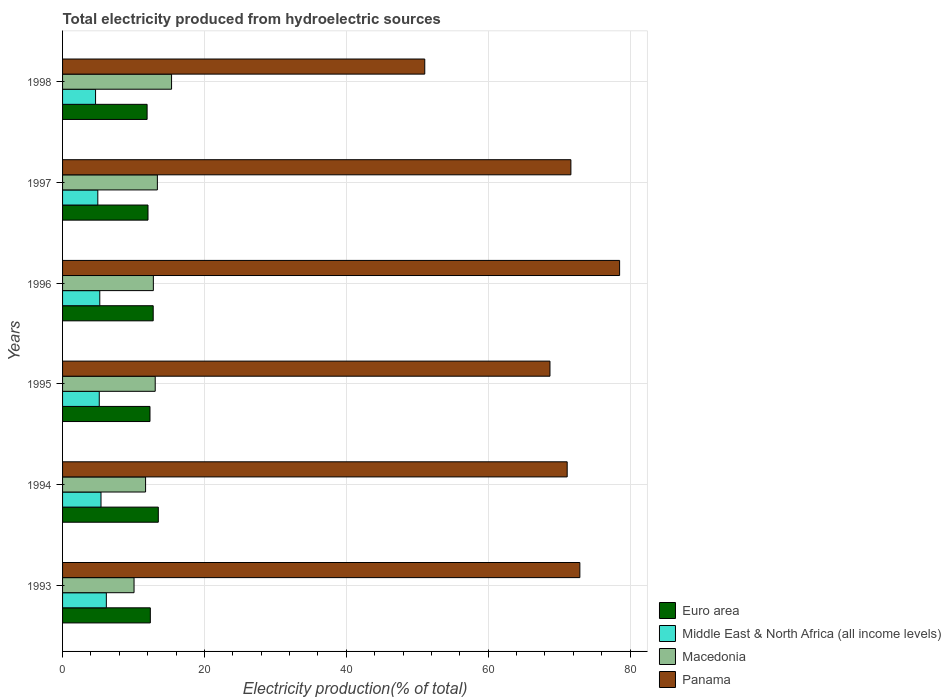How many different coloured bars are there?
Provide a short and direct response. 4. How many groups of bars are there?
Give a very brief answer. 6. Are the number of bars on each tick of the Y-axis equal?
Provide a short and direct response. Yes. How many bars are there on the 4th tick from the top?
Offer a terse response. 4. What is the total electricity produced in Euro area in 1996?
Keep it short and to the point. 12.78. Across all years, what is the maximum total electricity produced in Macedonia?
Offer a terse response. 15.37. Across all years, what is the minimum total electricity produced in Euro area?
Offer a terse response. 11.92. What is the total total electricity produced in Euro area in the graph?
Offer a very short reply. 74.93. What is the difference between the total electricity produced in Panama in 1994 and that in 1995?
Your answer should be very brief. 2.43. What is the difference between the total electricity produced in Panama in 1994 and the total electricity produced in Macedonia in 1998?
Offer a very short reply. 55.77. What is the average total electricity produced in Euro area per year?
Your answer should be very brief. 12.49. In the year 1995, what is the difference between the total electricity produced in Panama and total electricity produced in Middle East & North Africa (all income levels)?
Make the answer very short. 63.54. What is the ratio of the total electricity produced in Middle East & North Africa (all income levels) in 1994 to that in 1997?
Keep it short and to the point. 1.09. What is the difference between the highest and the second highest total electricity produced in Euro area?
Provide a succinct answer. 0.72. What is the difference between the highest and the lowest total electricity produced in Middle East & North Africa (all income levels)?
Offer a terse response. 1.52. Is the sum of the total electricity produced in Euro area in 1994 and 1995 greater than the maximum total electricity produced in Middle East & North Africa (all income levels) across all years?
Make the answer very short. Yes. What does the 3rd bar from the top in 1998 represents?
Provide a succinct answer. Middle East & North Africa (all income levels). What does the 1st bar from the bottom in 1995 represents?
Offer a very short reply. Euro area. Are all the bars in the graph horizontal?
Your response must be concise. Yes. Are the values on the major ticks of X-axis written in scientific E-notation?
Your answer should be compact. No. How many legend labels are there?
Your answer should be very brief. 4. How are the legend labels stacked?
Offer a terse response. Vertical. What is the title of the graph?
Your response must be concise. Total electricity produced from hydroelectric sources. Does "Uzbekistan" appear as one of the legend labels in the graph?
Ensure brevity in your answer.  No. What is the label or title of the X-axis?
Provide a succinct answer. Electricity production(% of total). What is the label or title of the Y-axis?
Ensure brevity in your answer.  Years. What is the Electricity production(% of total) in Euro area in 1993?
Give a very brief answer. 12.37. What is the Electricity production(% of total) in Middle East & North Africa (all income levels) in 1993?
Offer a very short reply. 6.17. What is the Electricity production(% of total) of Macedonia in 1993?
Your answer should be very brief. 10.08. What is the Electricity production(% of total) of Panama in 1993?
Offer a very short reply. 72.93. What is the Electricity production(% of total) of Euro area in 1994?
Your response must be concise. 13.5. What is the Electricity production(% of total) of Middle East & North Africa (all income levels) in 1994?
Give a very brief answer. 5.42. What is the Electricity production(% of total) of Macedonia in 1994?
Your answer should be very brief. 11.7. What is the Electricity production(% of total) in Panama in 1994?
Give a very brief answer. 71.14. What is the Electricity production(% of total) in Euro area in 1995?
Provide a succinct answer. 12.32. What is the Electricity production(% of total) of Middle East & North Africa (all income levels) in 1995?
Offer a very short reply. 5.17. What is the Electricity production(% of total) of Macedonia in 1995?
Offer a very short reply. 13.06. What is the Electricity production(% of total) of Panama in 1995?
Keep it short and to the point. 68.71. What is the Electricity production(% of total) in Euro area in 1996?
Give a very brief answer. 12.78. What is the Electricity production(% of total) of Middle East & North Africa (all income levels) in 1996?
Your answer should be very brief. 5.25. What is the Electricity production(% of total) of Macedonia in 1996?
Ensure brevity in your answer.  12.8. What is the Electricity production(% of total) of Panama in 1996?
Give a very brief answer. 78.53. What is the Electricity production(% of total) in Euro area in 1997?
Give a very brief answer. 12.04. What is the Electricity production(% of total) in Middle East & North Africa (all income levels) in 1997?
Offer a very short reply. 4.97. What is the Electricity production(% of total) of Macedonia in 1997?
Provide a short and direct response. 13.37. What is the Electricity production(% of total) of Panama in 1997?
Offer a very short reply. 71.66. What is the Electricity production(% of total) of Euro area in 1998?
Provide a succinct answer. 11.92. What is the Electricity production(% of total) in Middle East & North Africa (all income levels) in 1998?
Offer a very short reply. 4.65. What is the Electricity production(% of total) in Macedonia in 1998?
Keep it short and to the point. 15.37. What is the Electricity production(% of total) of Panama in 1998?
Provide a short and direct response. 51.06. Across all years, what is the maximum Electricity production(% of total) in Euro area?
Your answer should be compact. 13.5. Across all years, what is the maximum Electricity production(% of total) in Middle East & North Africa (all income levels)?
Provide a short and direct response. 6.17. Across all years, what is the maximum Electricity production(% of total) in Macedonia?
Provide a succinct answer. 15.37. Across all years, what is the maximum Electricity production(% of total) in Panama?
Provide a short and direct response. 78.53. Across all years, what is the minimum Electricity production(% of total) in Euro area?
Provide a short and direct response. 11.92. Across all years, what is the minimum Electricity production(% of total) of Middle East & North Africa (all income levels)?
Ensure brevity in your answer.  4.65. Across all years, what is the minimum Electricity production(% of total) in Macedonia?
Provide a succinct answer. 10.08. Across all years, what is the minimum Electricity production(% of total) of Panama?
Give a very brief answer. 51.06. What is the total Electricity production(% of total) of Euro area in the graph?
Offer a terse response. 74.93. What is the total Electricity production(% of total) in Middle East & North Africa (all income levels) in the graph?
Give a very brief answer. 31.63. What is the total Electricity production(% of total) in Macedonia in the graph?
Your response must be concise. 76.37. What is the total Electricity production(% of total) of Panama in the graph?
Provide a short and direct response. 414.03. What is the difference between the Electricity production(% of total) of Euro area in 1993 and that in 1994?
Offer a terse response. -1.13. What is the difference between the Electricity production(% of total) of Middle East & North Africa (all income levels) in 1993 and that in 1994?
Your answer should be very brief. 0.75. What is the difference between the Electricity production(% of total) in Macedonia in 1993 and that in 1994?
Ensure brevity in your answer.  -1.63. What is the difference between the Electricity production(% of total) of Panama in 1993 and that in 1994?
Offer a terse response. 1.79. What is the difference between the Electricity production(% of total) of Euro area in 1993 and that in 1995?
Provide a succinct answer. 0.05. What is the difference between the Electricity production(% of total) of Macedonia in 1993 and that in 1995?
Keep it short and to the point. -2.99. What is the difference between the Electricity production(% of total) of Panama in 1993 and that in 1995?
Make the answer very short. 4.21. What is the difference between the Electricity production(% of total) of Euro area in 1993 and that in 1996?
Offer a terse response. -0.41. What is the difference between the Electricity production(% of total) of Middle East & North Africa (all income levels) in 1993 and that in 1996?
Your response must be concise. 0.93. What is the difference between the Electricity production(% of total) of Macedonia in 1993 and that in 1996?
Provide a succinct answer. -2.72. What is the difference between the Electricity production(% of total) in Panama in 1993 and that in 1996?
Give a very brief answer. -5.6. What is the difference between the Electricity production(% of total) of Euro area in 1993 and that in 1997?
Your answer should be very brief. 0.33. What is the difference between the Electricity production(% of total) of Middle East & North Africa (all income levels) in 1993 and that in 1997?
Your answer should be very brief. 1.2. What is the difference between the Electricity production(% of total) in Macedonia in 1993 and that in 1997?
Provide a short and direct response. -3.29. What is the difference between the Electricity production(% of total) of Panama in 1993 and that in 1997?
Your answer should be very brief. 1.27. What is the difference between the Electricity production(% of total) of Euro area in 1993 and that in 1998?
Your answer should be compact. 0.45. What is the difference between the Electricity production(% of total) of Middle East & North Africa (all income levels) in 1993 and that in 1998?
Offer a terse response. 1.52. What is the difference between the Electricity production(% of total) of Macedonia in 1993 and that in 1998?
Provide a succinct answer. -5.29. What is the difference between the Electricity production(% of total) of Panama in 1993 and that in 1998?
Ensure brevity in your answer.  21.86. What is the difference between the Electricity production(% of total) of Euro area in 1994 and that in 1995?
Provide a short and direct response. 1.17. What is the difference between the Electricity production(% of total) of Middle East & North Africa (all income levels) in 1994 and that in 1995?
Your answer should be very brief. 0.25. What is the difference between the Electricity production(% of total) in Macedonia in 1994 and that in 1995?
Your answer should be compact. -1.36. What is the difference between the Electricity production(% of total) of Panama in 1994 and that in 1995?
Offer a very short reply. 2.43. What is the difference between the Electricity production(% of total) of Euro area in 1994 and that in 1996?
Make the answer very short. 0.72. What is the difference between the Electricity production(% of total) in Middle East & North Africa (all income levels) in 1994 and that in 1996?
Offer a terse response. 0.17. What is the difference between the Electricity production(% of total) of Macedonia in 1994 and that in 1996?
Your answer should be compact. -1.1. What is the difference between the Electricity production(% of total) in Panama in 1994 and that in 1996?
Make the answer very short. -7.39. What is the difference between the Electricity production(% of total) of Euro area in 1994 and that in 1997?
Offer a very short reply. 1.45. What is the difference between the Electricity production(% of total) of Middle East & North Africa (all income levels) in 1994 and that in 1997?
Your answer should be compact. 0.45. What is the difference between the Electricity production(% of total) in Macedonia in 1994 and that in 1997?
Provide a short and direct response. -1.66. What is the difference between the Electricity production(% of total) of Panama in 1994 and that in 1997?
Provide a succinct answer. -0.52. What is the difference between the Electricity production(% of total) in Euro area in 1994 and that in 1998?
Keep it short and to the point. 1.58. What is the difference between the Electricity production(% of total) of Middle East & North Africa (all income levels) in 1994 and that in 1998?
Offer a very short reply. 0.77. What is the difference between the Electricity production(% of total) of Macedonia in 1994 and that in 1998?
Provide a short and direct response. -3.66. What is the difference between the Electricity production(% of total) of Panama in 1994 and that in 1998?
Give a very brief answer. 20.08. What is the difference between the Electricity production(% of total) in Euro area in 1995 and that in 1996?
Provide a succinct answer. -0.45. What is the difference between the Electricity production(% of total) of Middle East & North Africa (all income levels) in 1995 and that in 1996?
Your answer should be very brief. -0.07. What is the difference between the Electricity production(% of total) of Macedonia in 1995 and that in 1996?
Your answer should be very brief. 0.26. What is the difference between the Electricity production(% of total) of Panama in 1995 and that in 1996?
Provide a succinct answer. -9.82. What is the difference between the Electricity production(% of total) in Euro area in 1995 and that in 1997?
Offer a terse response. 0.28. What is the difference between the Electricity production(% of total) of Middle East & North Africa (all income levels) in 1995 and that in 1997?
Offer a very short reply. 0.21. What is the difference between the Electricity production(% of total) in Macedonia in 1995 and that in 1997?
Ensure brevity in your answer.  -0.3. What is the difference between the Electricity production(% of total) of Panama in 1995 and that in 1997?
Provide a succinct answer. -2.95. What is the difference between the Electricity production(% of total) in Euro area in 1995 and that in 1998?
Ensure brevity in your answer.  0.41. What is the difference between the Electricity production(% of total) in Middle East & North Africa (all income levels) in 1995 and that in 1998?
Make the answer very short. 0.52. What is the difference between the Electricity production(% of total) of Macedonia in 1995 and that in 1998?
Your response must be concise. -2.3. What is the difference between the Electricity production(% of total) in Panama in 1995 and that in 1998?
Provide a succinct answer. 17.65. What is the difference between the Electricity production(% of total) in Euro area in 1996 and that in 1997?
Offer a very short reply. 0.73. What is the difference between the Electricity production(% of total) of Middle East & North Africa (all income levels) in 1996 and that in 1997?
Provide a succinct answer. 0.28. What is the difference between the Electricity production(% of total) of Macedonia in 1996 and that in 1997?
Make the answer very short. -0.57. What is the difference between the Electricity production(% of total) in Panama in 1996 and that in 1997?
Give a very brief answer. 6.87. What is the difference between the Electricity production(% of total) in Euro area in 1996 and that in 1998?
Ensure brevity in your answer.  0.86. What is the difference between the Electricity production(% of total) of Middle East & North Africa (all income levels) in 1996 and that in 1998?
Give a very brief answer. 0.59. What is the difference between the Electricity production(% of total) of Macedonia in 1996 and that in 1998?
Offer a very short reply. -2.57. What is the difference between the Electricity production(% of total) of Panama in 1996 and that in 1998?
Offer a terse response. 27.47. What is the difference between the Electricity production(% of total) in Euro area in 1997 and that in 1998?
Give a very brief answer. 0.13. What is the difference between the Electricity production(% of total) in Middle East & North Africa (all income levels) in 1997 and that in 1998?
Give a very brief answer. 0.32. What is the difference between the Electricity production(% of total) in Macedonia in 1997 and that in 1998?
Your answer should be very brief. -2. What is the difference between the Electricity production(% of total) in Panama in 1997 and that in 1998?
Provide a short and direct response. 20.6. What is the difference between the Electricity production(% of total) of Euro area in 1993 and the Electricity production(% of total) of Middle East & North Africa (all income levels) in 1994?
Keep it short and to the point. 6.95. What is the difference between the Electricity production(% of total) in Euro area in 1993 and the Electricity production(% of total) in Macedonia in 1994?
Your answer should be compact. 0.67. What is the difference between the Electricity production(% of total) in Euro area in 1993 and the Electricity production(% of total) in Panama in 1994?
Provide a succinct answer. -58.77. What is the difference between the Electricity production(% of total) of Middle East & North Africa (all income levels) in 1993 and the Electricity production(% of total) of Macedonia in 1994?
Offer a terse response. -5.53. What is the difference between the Electricity production(% of total) in Middle East & North Africa (all income levels) in 1993 and the Electricity production(% of total) in Panama in 1994?
Keep it short and to the point. -64.97. What is the difference between the Electricity production(% of total) of Macedonia in 1993 and the Electricity production(% of total) of Panama in 1994?
Ensure brevity in your answer.  -61.06. What is the difference between the Electricity production(% of total) in Euro area in 1993 and the Electricity production(% of total) in Middle East & North Africa (all income levels) in 1995?
Your response must be concise. 7.2. What is the difference between the Electricity production(% of total) of Euro area in 1993 and the Electricity production(% of total) of Macedonia in 1995?
Keep it short and to the point. -0.69. What is the difference between the Electricity production(% of total) of Euro area in 1993 and the Electricity production(% of total) of Panama in 1995?
Ensure brevity in your answer.  -56.34. What is the difference between the Electricity production(% of total) in Middle East & North Africa (all income levels) in 1993 and the Electricity production(% of total) in Macedonia in 1995?
Your answer should be compact. -6.89. What is the difference between the Electricity production(% of total) in Middle East & North Africa (all income levels) in 1993 and the Electricity production(% of total) in Panama in 1995?
Your answer should be compact. -62.54. What is the difference between the Electricity production(% of total) of Macedonia in 1993 and the Electricity production(% of total) of Panama in 1995?
Keep it short and to the point. -58.64. What is the difference between the Electricity production(% of total) in Euro area in 1993 and the Electricity production(% of total) in Middle East & North Africa (all income levels) in 1996?
Ensure brevity in your answer.  7.13. What is the difference between the Electricity production(% of total) in Euro area in 1993 and the Electricity production(% of total) in Macedonia in 1996?
Keep it short and to the point. -0.43. What is the difference between the Electricity production(% of total) of Euro area in 1993 and the Electricity production(% of total) of Panama in 1996?
Provide a short and direct response. -66.16. What is the difference between the Electricity production(% of total) of Middle East & North Africa (all income levels) in 1993 and the Electricity production(% of total) of Macedonia in 1996?
Keep it short and to the point. -6.63. What is the difference between the Electricity production(% of total) of Middle East & North Africa (all income levels) in 1993 and the Electricity production(% of total) of Panama in 1996?
Provide a succinct answer. -72.36. What is the difference between the Electricity production(% of total) of Macedonia in 1993 and the Electricity production(% of total) of Panama in 1996?
Offer a very short reply. -68.45. What is the difference between the Electricity production(% of total) of Euro area in 1993 and the Electricity production(% of total) of Middle East & North Africa (all income levels) in 1997?
Your response must be concise. 7.4. What is the difference between the Electricity production(% of total) in Euro area in 1993 and the Electricity production(% of total) in Macedonia in 1997?
Ensure brevity in your answer.  -0.99. What is the difference between the Electricity production(% of total) in Euro area in 1993 and the Electricity production(% of total) in Panama in 1997?
Make the answer very short. -59.29. What is the difference between the Electricity production(% of total) of Middle East & North Africa (all income levels) in 1993 and the Electricity production(% of total) of Macedonia in 1997?
Your answer should be compact. -7.2. What is the difference between the Electricity production(% of total) in Middle East & North Africa (all income levels) in 1993 and the Electricity production(% of total) in Panama in 1997?
Make the answer very short. -65.49. What is the difference between the Electricity production(% of total) of Macedonia in 1993 and the Electricity production(% of total) of Panama in 1997?
Keep it short and to the point. -61.58. What is the difference between the Electricity production(% of total) of Euro area in 1993 and the Electricity production(% of total) of Middle East & North Africa (all income levels) in 1998?
Your response must be concise. 7.72. What is the difference between the Electricity production(% of total) in Euro area in 1993 and the Electricity production(% of total) in Macedonia in 1998?
Your answer should be very brief. -2.99. What is the difference between the Electricity production(% of total) in Euro area in 1993 and the Electricity production(% of total) in Panama in 1998?
Make the answer very short. -38.69. What is the difference between the Electricity production(% of total) of Middle East & North Africa (all income levels) in 1993 and the Electricity production(% of total) of Macedonia in 1998?
Give a very brief answer. -9.19. What is the difference between the Electricity production(% of total) of Middle East & North Africa (all income levels) in 1993 and the Electricity production(% of total) of Panama in 1998?
Your answer should be very brief. -44.89. What is the difference between the Electricity production(% of total) in Macedonia in 1993 and the Electricity production(% of total) in Panama in 1998?
Provide a short and direct response. -40.98. What is the difference between the Electricity production(% of total) of Euro area in 1994 and the Electricity production(% of total) of Middle East & North Africa (all income levels) in 1995?
Your response must be concise. 8.32. What is the difference between the Electricity production(% of total) in Euro area in 1994 and the Electricity production(% of total) in Macedonia in 1995?
Your answer should be very brief. 0.43. What is the difference between the Electricity production(% of total) in Euro area in 1994 and the Electricity production(% of total) in Panama in 1995?
Make the answer very short. -55.22. What is the difference between the Electricity production(% of total) of Middle East & North Africa (all income levels) in 1994 and the Electricity production(% of total) of Macedonia in 1995?
Your answer should be compact. -7.64. What is the difference between the Electricity production(% of total) of Middle East & North Africa (all income levels) in 1994 and the Electricity production(% of total) of Panama in 1995?
Give a very brief answer. -63.29. What is the difference between the Electricity production(% of total) in Macedonia in 1994 and the Electricity production(% of total) in Panama in 1995?
Keep it short and to the point. -57.01. What is the difference between the Electricity production(% of total) in Euro area in 1994 and the Electricity production(% of total) in Middle East & North Africa (all income levels) in 1996?
Give a very brief answer. 8.25. What is the difference between the Electricity production(% of total) of Euro area in 1994 and the Electricity production(% of total) of Macedonia in 1996?
Offer a very short reply. 0.7. What is the difference between the Electricity production(% of total) in Euro area in 1994 and the Electricity production(% of total) in Panama in 1996?
Your answer should be compact. -65.03. What is the difference between the Electricity production(% of total) in Middle East & North Africa (all income levels) in 1994 and the Electricity production(% of total) in Macedonia in 1996?
Your answer should be very brief. -7.38. What is the difference between the Electricity production(% of total) in Middle East & North Africa (all income levels) in 1994 and the Electricity production(% of total) in Panama in 1996?
Offer a terse response. -73.11. What is the difference between the Electricity production(% of total) of Macedonia in 1994 and the Electricity production(% of total) of Panama in 1996?
Provide a short and direct response. -66.83. What is the difference between the Electricity production(% of total) in Euro area in 1994 and the Electricity production(% of total) in Middle East & North Africa (all income levels) in 1997?
Your answer should be compact. 8.53. What is the difference between the Electricity production(% of total) in Euro area in 1994 and the Electricity production(% of total) in Macedonia in 1997?
Provide a short and direct response. 0.13. What is the difference between the Electricity production(% of total) in Euro area in 1994 and the Electricity production(% of total) in Panama in 1997?
Offer a terse response. -58.16. What is the difference between the Electricity production(% of total) in Middle East & North Africa (all income levels) in 1994 and the Electricity production(% of total) in Macedonia in 1997?
Give a very brief answer. -7.95. What is the difference between the Electricity production(% of total) in Middle East & North Africa (all income levels) in 1994 and the Electricity production(% of total) in Panama in 1997?
Offer a very short reply. -66.24. What is the difference between the Electricity production(% of total) in Macedonia in 1994 and the Electricity production(% of total) in Panama in 1997?
Your answer should be very brief. -59.96. What is the difference between the Electricity production(% of total) of Euro area in 1994 and the Electricity production(% of total) of Middle East & North Africa (all income levels) in 1998?
Give a very brief answer. 8.85. What is the difference between the Electricity production(% of total) of Euro area in 1994 and the Electricity production(% of total) of Macedonia in 1998?
Your response must be concise. -1.87. What is the difference between the Electricity production(% of total) of Euro area in 1994 and the Electricity production(% of total) of Panama in 1998?
Offer a terse response. -37.56. What is the difference between the Electricity production(% of total) of Middle East & North Africa (all income levels) in 1994 and the Electricity production(% of total) of Macedonia in 1998?
Offer a very short reply. -9.95. What is the difference between the Electricity production(% of total) of Middle East & North Africa (all income levels) in 1994 and the Electricity production(% of total) of Panama in 1998?
Make the answer very short. -45.64. What is the difference between the Electricity production(% of total) of Macedonia in 1994 and the Electricity production(% of total) of Panama in 1998?
Offer a very short reply. -39.36. What is the difference between the Electricity production(% of total) in Euro area in 1995 and the Electricity production(% of total) in Middle East & North Africa (all income levels) in 1996?
Provide a succinct answer. 7.08. What is the difference between the Electricity production(% of total) of Euro area in 1995 and the Electricity production(% of total) of Macedonia in 1996?
Keep it short and to the point. -0.47. What is the difference between the Electricity production(% of total) in Euro area in 1995 and the Electricity production(% of total) in Panama in 1996?
Your answer should be compact. -66.21. What is the difference between the Electricity production(% of total) in Middle East & North Africa (all income levels) in 1995 and the Electricity production(% of total) in Macedonia in 1996?
Offer a terse response. -7.63. What is the difference between the Electricity production(% of total) in Middle East & North Africa (all income levels) in 1995 and the Electricity production(% of total) in Panama in 1996?
Keep it short and to the point. -73.36. What is the difference between the Electricity production(% of total) in Macedonia in 1995 and the Electricity production(% of total) in Panama in 1996?
Your answer should be very brief. -65.47. What is the difference between the Electricity production(% of total) in Euro area in 1995 and the Electricity production(% of total) in Middle East & North Africa (all income levels) in 1997?
Your answer should be very brief. 7.36. What is the difference between the Electricity production(% of total) in Euro area in 1995 and the Electricity production(% of total) in Macedonia in 1997?
Your answer should be compact. -1.04. What is the difference between the Electricity production(% of total) of Euro area in 1995 and the Electricity production(% of total) of Panama in 1997?
Keep it short and to the point. -59.34. What is the difference between the Electricity production(% of total) of Middle East & North Africa (all income levels) in 1995 and the Electricity production(% of total) of Macedonia in 1997?
Your response must be concise. -8.19. What is the difference between the Electricity production(% of total) of Middle East & North Africa (all income levels) in 1995 and the Electricity production(% of total) of Panama in 1997?
Ensure brevity in your answer.  -66.49. What is the difference between the Electricity production(% of total) in Macedonia in 1995 and the Electricity production(% of total) in Panama in 1997?
Make the answer very short. -58.6. What is the difference between the Electricity production(% of total) in Euro area in 1995 and the Electricity production(% of total) in Middle East & North Africa (all income levels) in 1998?
Provide a succinct answer. 7.67. What is the difference between the Electricity production(% of total) in Euro area in 1995 and the Electricity production(% of total) in Macedonia in 1998?
Offer a very short reply. -3.04. What is the difference between the Electricity production(% of total) in Euro area in 1995 and the Electricity production(% of total) in Panama in 1998?
Keep it short and to the point. -38.74. What is the difference between the Electricity production(% of total) of Middle East & North Africa (all income levels) in 1995 and the Electricity production(% of total) of Macedonia in 1998?
Give a very brief answer. -10.19. What is the difference between the Electricity production(% of total) in Middle East & North Africa (all income levels) in 1995 and the Electricity production(% of total) in Panama in 1998?
Provide a short and direct response. -45.89. What is the difference between the Electricity production(% of total) in Macedonia in 1995 and the Electricity production(% of total) in Panama in 1998?
Ensure brevity in your answer.  -38. What is the difference between the Electricity production(% of total) of Euro area in 1996 and the Electricity production(% of total) of Middle East & North Africa (all income levels) in 1997?
Ensure brevity in your answer.  7.81. What is the difference between the Electricity production(% of total) in Euro area in 1996 and the Electricity production(% of total) in Macedonia in 1997?
Your answer should be compact. -0.59. What is the difference between the Electricity production(% of total) of Euro area in 1996 and the Electricity production(% of total) of Panama in 1997?
Keep it short and to the point. -58.88. What is the difference between the Electricity production(% of total) in Middle East & North Africa (all income levels) in 1996 and the Electricity production(% of total) in Macedonia in 1997?
Give a very brief answer. -8.12. What is the difference between the Electricity production(% of total) in Middle East & North Africa (all income levels) in 1996 and the Electricity production(% of total) in Panama in 1997?
Give a very brief answer. -66.42. What is the difference between the Electricity production(% of total) in Macedonia in 1996 and the Electricity production(% of total) in Panama in 1997?
Make the answer very short. -58.86. What is the difference between the Electricity production(% of total) of Euro area in 1996 and the Electricity production(% of total) of Middle East & North Africa (all income levels) in 1998?
Ensure brevity in your answer.  8.13. What is the difference between the Electricity production(% of total) in Euro area in 1996 and the Electricity production(% of total) in Macedonia in 1998?
Provide a short and direct response. -2.59. What is the difference between the Electricity production(% of total) in Euro area in 1996 and the Electricity production(% of total) in Panama in 1998?
Offer a terse response. -38.28. What is the difference between the Electricity production(% of total) of Middle East & North Africa (all income levels) in 1996 and the Electricity production(% of total) of Macedonia in 1998?
Provide a short and direct response. -10.12. What is the difference between the Electricity production(% of total) in Middle East & North Africa (all income levels) in 1996 and the Electricity production(% of total) in Panama in 1998?
Keep it short and to the point. -45.82. What is the difference between the Electricity production(% of total) in Macedonia in 1996 and the Electricity production(% of total) in Panama in 1998?
Give a very brief answer. -38.26. What is the difference between the Electricity production(% of total) in Euro area in 1997 and the Electricity production(% of total) in Middle East & North Africa (all income levels) in 1998?
Ensure brevity in your answer.  7.39. What is the difference between the Electricity production(% of total) of Euro area in 1997 and the Electricity production(% of total) of Macedonia in 1998?
Offer a terse response. -3.32. What is the difference between the Electricity production(% of total) in Euro area in 1997 and the Electricity production(% of total) in Panama in 1998?
Make the answer very short. -39.02. What is the difference between the Electricity production(% of total) of Middle East & North Africa (all income levels) in 1997 and the Electricity production(% of total) of Macedonia in 1998?
Your response must be concise. -10.4. What is the difference between the Electricity production(% of total) of Middle East & North Africa (all income levels) in 1997 and the Electricity production(% of total) of Panama in 1998?
Provide a short and direct response. -46.09. What is the difference between the Electricity production(% of total) in Macedonia in 1997 and the Electricity production(% of total) in Panama in 1998?
Provide a short and direct response. -37.69. What is the average Electricity production(% of total) of Euro area per year?
Offer a terse response. 12.49. What is the average Electricity production(% of total) of Middle East & North Africa (all income levels) per year?
Provide a succinct answer. 5.27. What is the average Electricity production(% of total) in Macedonia per year?
Provide a succinct answer. 12.73. What is the average Electricity production(% of total) in Panama per year?
Provide a short and direct response. 69.01. In the year 1993, what is the difference between the Electricity production(% of total) of Euro area and Electricity production(% of total) of Middle East & North Africa (all income levels)?
Offer a very short reply. 6.2. In the year 1993, what is the difference between the Electricity production(% of total) of Euro area and Electricity production(% of total) of Macedonia?
Make the answer very short. 2.29. In the year 1993, what is the difference between the Electricity production(% of total) of Euro area and Electricity production(% of total) of Panama?
Your answer should be very brief. -60.55. In the year 1993, what is the difference between the Electricity production(% of total) of Middle East & North Africa (all income levels) and Electricity production(% of total) of Macedonia?
Make the answer very short. -3.91. In the year 1993, what is the difference between the Electricity production(% of total) of Middle East & North Africa (all income levels) and Electricity production(% of total) of Panama?
Keep it short and to the point. -66.75. In the year 1993, what is the difference between the Electricity production(% of total) in Macedonia and Electricity production(% of total) in Panama?
Ensure brevity in your answer.  -62.85. In the year 1994, what is the difference between the Electricity production(% of total) of Euro area and Electricity production(% of total) of Middle East & North Africa (all income levels)?
Give a very brief answer. 8.08. In the year 1994, what is the difference between the Electricity production(% of total) in Euro area and Electricity production(% of total) in Macedonia?
Your response must be concise. 1.8. In the year 1994, what is the difference between the Electricity production(% of total) of Euro area and Electricity production(% of total) of Panama?
Keep it short and to the point. -57.64. In the year 1994, what is the difference between the Electricity production(% of total) in Middle East & North Africa (all income levels) and Electricity production(% of total) in Macedonia?
Provide a short and direct response. -6.28. In the year 1994, what is the difference between the Electricity production(% of total) in Middle East & North Africa (all income levels) and Electricity production(% of total) in Panama?
Provide a succinct answer. -65.72. In the year 1994, what is the difference between the Electricity production(% of total) of Macedonia and Electricity production(% of total) of Panama?
Your answer should be very brief. -59.44. In the year 1995, what is the difference between the Electricity production(% of total) in Euro area and Electricity production(% of total) in Middle East & North Africa (all income levels)?
Your answer should be very brief. 7.15. In the year 1995, what is the difference between the Electricity production(% of total) in Euro area and Electricity production(% of total) in Macedonia?
Make the answer very short. -0.74. In the year 1995, what is the difference between the Electricity production(% of total) in Euro area and Electricity production(% of total) in Panama?
Offer a terse response. -56.39. In the year 1995, what is the difference between the Electricity production(% of total) in Middle East & North Africa (all income levels) and Electricity production(% of total) in Macedonia?
Provide a succinct answer. -7.89. In the year 1995, what is the difference between the Electricity production(% of total) of Middle East & North Africa (all income levels) and Electricity production(% of total) of Panama?
Make the answer very short. -63.54. In the year 1995, what is the difference between the Electricity production(% of total) in Macedonia and Electricity production(% of total) in Panama?
Provide a short and direct response. -55.65. In the year 1996, what is the difference between the Electricity production(% of total) in Euro area and Electricity production(% of total) in Middle East & North Africa (all income levels)?
Offer a very short reply. 7.53. In the year 1996, what is the difference between the Electricity production(% of total) in Euro area and Electricity production(% of total) in Macedonia?
Your answer should be very brief. -0.02. In the year 1996, what is the difference between the Electricity production(% of total) in Euro area and Electricity production(% of total) in Panama?
Give a very brief answer. -65.75. In the year 1996, what is the difference between the Electricity production(% of total) in Middle East & North Africa (all income levels) and Electricity production(% of total) in Macedonia?
Provide a succinct answer. -7.55. In the year 1996, what is the difference between the Electricity production(% of total) of Middle East & North Africa (all income levels) and Electricity production(% of total) of Panama?
Give a very brief answer. -73.28. In the year 1996, what is the difference between the Electricity production(% of total) in Macedonia and Electricity production(% of total) in Panama?
Keep it short and to the point. -65.73. In the year 1997, what is the difference between the Electricity production(% of total) of Euro area and Electricity production(% of total) of Middle East & North Africa (all income levels)?
Your answer should be compact. 7.08. In the year 1997, what is the difference between the Electricity production(% of total) of Euro area and Electricity production(% of total) of Macedonia?
Ensure brevity in your answer.  -1.32. In the year 1997, what is the difference between the Electricity production(% of total) of Euro area and Electricity production(% of total) of Panama?
Your answer should be compact. -59.62. In the year 1997, what is the difference between the Electricity production(% of total) of Middle East & North Africa (all income levels) and Electricity production(% of total) of Macedonia?
Provide a succinct answer. -8.4. In the year 1997, what is the difference between the Electricity production(% of total) in Middle East & North Africa (all income levels) and Electricity production(% of total) in Panama?
Offer a terse response. -66.69. In the year 1997, what is the difference between the Electricity production(% of total) in Macedonia and Electricity production(% of total) in Panama?
Your response must be concise. -58.29. In the year 1998, what is the difference between the Electricity production(% of total) in Euro area and Electricity production(% of total) in Middle East & North Africa (all income levels)?
Offer a terse response. 7.27. In the year 1998, what is the difference between the Electricity production(% of total) of Euro area and Electricity production(% of total) of Macedonia?
Offer a very short reply. -3.45. In the year 1998, what is the difference between the Electricity production(% of total) in Euro area and Electricity production(% of total) in Panama?
Provide a succinct answer. -39.14. In the year 1998, what is the difference between the Electricity production(% of total) of Middle East & North Africa (all income levels) and Electricity production(% of total) of Macedonia?
Ensure brevity in your answer.  -10.71. In the year 1998, what is the difference between the Electricity production(% of total) in Middle East & North Africa (all income levels) and Electricity production(% of total) in Panama?
Offer a terse response. -46.41. In the year 1998, what is the difference between the Electricity production(% of total) of Macedonia and Electricity production(% of total) of Panama?
Your answer should be compact. -35.7. What is the ratio of the Electricity production(% of total) of Euro area in 1993 to that in 1994?
Make the answer very short. 0.92. What is the ratio of the Electricity production(% of total) of Middle East & North Africa (all income levels) in 1993 to that in 1994?
Your answer should be compact. 1.14. What is the ratio of the Electricity production(% of total) in Macedonia in 1993 to that in 1994?
Ensure brevity in your answer.  0.86. What is the ratio of the Electricity production(% of total) of Panama in 1993 to that in 1994?
Provide a short and direct response. 1.03. What is the ratio of the Electricity production(% of total) of Middle East & North Africa (all income levels) in 1993 to that in 1995?
Your answer should be very brief. 1.19. What is the ratio of the Electricity production(% of total) of Macedonia in 1993 to that in 1995?
Your answer should be compact. 0.77. What is the ratio of the Electricity production(% of total) in Panama in 1993 to that in 1995?
Offer a terse response. 1.06. What is the ratio of the Electricity production(% of total) in Euro area in 1993 to that in 1996?
Your answer should be very brief. 0.97. What is the ratio of the Electricity production(% of total) of Middle East & North Africa (all income levels) in 1993 to that in 1996?
Ensure brevity in your answer.  1.18. What is the ratio of the Electricity production(% of total) of Macedonia in 1993 to that in 1996?
Your response must be concise. 0.79. What is the ratio of the Electricity production(% of total) of Panama in 1993 to that in 1996?
Offer a very short reply. 0.93. What is the ratio of the Electricity production(% of total) of Euro area in 1993 to that in 1997?
Offer a very short reply. 1.03. What is the ratio of the Electricity production(% of total) of Middle East & North Africa (all income levels) in 1993 to that in 1997?
Provide a short and direct response. 1.24. What is the ratio of the Electricity production(% of total) of Macedonia in 1993 to that in 1997?
Provide a short and direct response. 0.75. What is the ratio of the Electricity production(% of total) in Panama in 1993 to that in 1997?
Your response must be concise. 1.02. What is the ratio of the Electricity production(% of total) in Euro area in 1993 to that in 1998?
Your answer should be very brief. 1.04. What is the ratio of the Electricity production(% of total) in Middle East & North Africa (all income levels) in 1993 to that in 1998?
Provide a short and direct response. 1.33. What is the ratio of the Electricity production(% of total) in Macedonia in 1993 to that in 1998?
Ensure brevity in your answer.  0.66. What is the ratio of the Electricity production(% of total) in Panama in 1993 to that in 1998?
Provide a succinct answer. 1.43. What is the ratio of the Electricity production(% of total) in Euro area in 1994 to that in 1995?
Provide a succinct answer. 1.1. What is the ratio of the Electricity production(% of total) in Middle East & North Africa (all income levels) in 1994 to that in 1995?
Offer a terse response. 1.05. What is the ratio of the Electricity production(% of total) of Macedonia in 1994 to that in 1995?
Offer a terse response. 0.9. What is the ratio of the Electricity production(% of total) of Panama in 1994 to that in 1995?
Offer a terse response. 1.04. What is the ratio of the Electricity production(% of total) in Euro area in 1994 to that in 1996?
Your answer should be compact. 1.06. What is the ratio of the Electricity production(% of total) of Middle East & North Africa (all income levels) in 1994 to that in 1996?
Offer a terse response. 1.03. What is the ratio of the Electricity production(% of total) of Macedonia in 1994 to that in 1996?
Provide a succinct answer. 0.91. What is the ratio of the Electricity production(% of total) of Panama in 1994 to that in 1996?
Offer a terse response. 0.91. What is the ratio of the Electricity production(% of total) in Euro area in 1994 to that in 1997?
Your response must be concise. 1.12. What is the ratio of the Electricity production(% of total) of Middle East & North Africa (all income levels) in 1994 to that in 1997?
Make the answer very short. 1.09. What is the ratio of the Electricity production(% of total) in Macedonia in 1994 to that in 1997?
Provide a succinct answer. 0.88. What is the ratio of the Electricity production(% of total) in Euro area in 1994 to that in 1998?
Provide a short and direct response. 1.13. What is the ratio of the Electricity production(% of total) of Middle East & North Africa (all income levels) in 1994 to that in 1998?
Your response must be concise. 1.16. What is the ratio of the Electricity production(% of total) in Macedonia in 1994 to that in 1998?
Your response must be concise. 0.76. What is the ratio of the Electricity production(% of total) in Panama in 1994 to that in 1998?
Your answer should be compact. 1.39. What is the ratio of the Electricity production(% of total) in Euro area in 1995 to that in 1996?
Offer a very short reply. 0.96. What is the ratio of the Electricity production(% of total) of Middle East & North Africa (all income levels) in 1995 to that in 1996?
Your answer should be compact. 0.99. What is the ratio of the Electricity production(% of total) of Macedonia in 1995 to that in 1996?
Provide a succinct answer. 1.02. What is the ratio of the Electricity production(% of total) of Euro area in 1995 to that in 1997?
Ensure brevity in your answer.  1.02. What is the ratio of the Electricity production(% of total) of Middle East & North Africa (all income levels) in 1995 to that in 1997?
Give a very brief answer. 1.04. What is the ratio of the Electricity production(% of total) of Macedonia in 1995 to that in 1997?
Your answer should be compact. 0.98. What is the ratio of the Electricity production(% of total) in Panama in 1995 to that in 1997?
Ensure brevity in your answer.  0.96. What is the ratio of the Electricity production(% of total) of Euro area in 1995 to that in 1998?
Keep it short and to the point. 1.03. What is the ratio of the Electricity production(% of total) in Middle East & North Africa (all income levels) in 1995 to that in 1998?
Your answer should be very brief. 1.11. What is the ratio of the Electricity production(% of total) of Macedonia in 1995 to that in 1998?
Your response must be concise. 0.85. What is the ratio of the Electricity production(% of total) in Panama in 1995 to that in 1998?
Your answer should be compact. 1.35. What is the ratio of the Electricity production(% of total) of Euro area in 1996 to that in 1997?
Your response must be concise. 1.06. What is the ratio of the Electricity production(% of total) in Middle East & North Africa (all income levels) in 1996 to that in 1997?
Give a very brief answer. 1.06. What is the ratio of the Electricity production(% of total) of Macedonia in 1996 to that in 1997?
Provide a short and direct response. 0.96. What is the ratio of the Electricity production(% of total) of Panama in 1996 to that in 1997?
Provide a succinct answer. 1.1. What is the ratio of the Electricity production(% of total) of Euro area in 1996 to that in 1998?
Ensure brevity in your answer.  1.07. What is the ratio of the Electricity production(% of total) in Middle East & North Africa (all income levels) in 1996 to that in 1998?
Your answer should be very brief. 1.13. What is the ratio of the Electricity production(% of total) of Macedonia in 1996 to that in 1998?
Offer a very short reply. 0.83. What is the ratio of the Electricity production(% of total) in Panama in 1996 to that in 1998?
Keep it short and to the point. 1.54. What is the ratio of the Electricity production(% of total) of Euro area in 1997 to that in 1998?
Keep it short and to the point. 1.01. What is the ratio of the Electricity production(% of total) of Middle East & North Africa (all income levels) in 1997 to that in 1998?
Provide a succinct answer. 1.07. What is the ratio of the Electricity production(% of total) in Macedonia in 1997 to that in 1998?
Keep it short and to the point. 0.87. What is the ratio of the Electricity production(% of total) in Panama in 1997 to that in 1998?
Give a very brief answer. 1.4. What is the difference between the highest and the second highest Electricity production(% of total) in Euro area?
Offer a terse response. 0.72. What is the difference between the highest and the second highest Electricity production(% of total) of Middle East & North Africa (all income levels)?
Make the answer very short. 0.75. What is the difference between the highest and the second highest Electricity production(% of total) of Macedonia?
Give a very brief answer. 2. What is the difference between the highest and the second highest Electricity production(% of total) of Panama?
Your answer should be very brief. 5.6. What is the difference between the highest and the lowest Electricity production(% of total) of Euro area?
Give a very brief answer. 1.58. What is the difference between the highest and the lowest Electricity production(% of total) of Middle East & North Africa (all income levels)?
Offer a very short reply. 1.52. What is the difference between the highest and the lowest Electricity production(% of total) in Macedonia?
Ensure brevity in your answer.  5.29. What is the difference between the highest and the lowest Electricity production(% of total) of Panama?
Offer a very short reply. 27.47. 